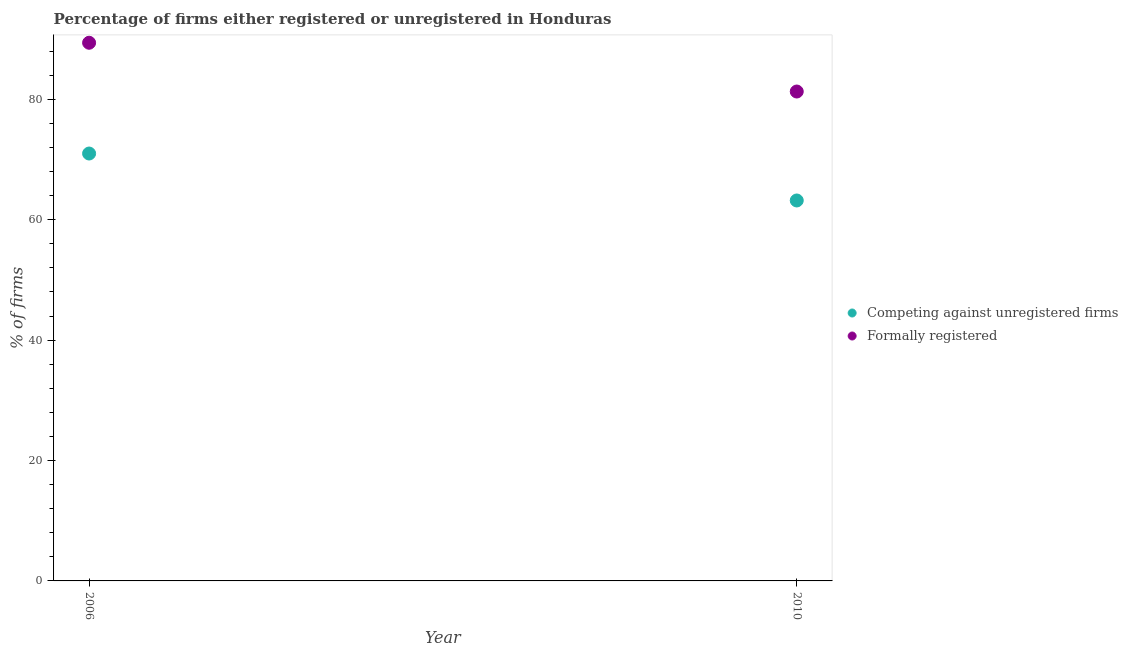Across all years, what is the maximum percentage of formally registered firms?
Give a very brief answer. 89.4. Across all years, what is the minimum percentage of formally registered firms?
Your answer should be very brief. 81.3. In which year was the percentage of registered firms maximum?
Your answer should be very brief. 2006. In which year was the percentage of formally registered firms minimum?
Your answer should be compact. 2010. What is the total percentage of formally registered firms in the graph?
Ensure brevity in your answer.  170.7. What is the difference between the percentage of formally registered firms in 2006 and that in 2010?
Your answer should be compact. 8.1. What is the difference between the percentage of formally registered firms in 2010 and the percentage of registered firms in 2006?
Your response must be concise. 10.3. What is the average percentage of formally registered firms per year?
Give a very brief answer. 85.35. In the year 2006, what is the difference between the percentage of registered firms and percentage of formally registered firms?
Your response must be concise. -18.4. What is the ratio of the percentage of formally registered firms in 2006 to that in 2010?
Give a very brief answer. 1.1. In how many years, is the percentage of registered firms greater than the average percentage of registered firms taken over all years?
Your answer should be compact. 1. Does the percentage of formally registered firms monotonically increase over the years?
Provide a short and direct response. No. Is the percentage of registered firms strictly less than the percentage of formally registered firms over the years?
Provide a succinct answer. Yes. How many years are there in the graph?
Offer a terse response. 2. Are the values on the major ticks of Y-axis written in scientific E-notation?
Offer a terse response. No. Where does the legend appear in the graph?
Provide a succinct answer. Center right. How many legend labels are there?
Offer a terse response. 2. How are the legend labels stacked?
Offer a very short reply. Vertical. What is the title of the graph?
Provide a short and direct response. Percentage of firms either registered or unregistered in Honduras. Does "Taxes on exports" appear as one of the legend labels in the graph?
Your response must be concise. No. What is the label or title of the Y-axis?
Ensure brevity in your answer.  % of firms. What is the % of firms of Formally registered in 2006?
Your answer should be compact. 89.4. What is the % of firms of Competing against unregistered firms in 2010?
Your answer should be compact. 63.2. What is the % of firms of Formally registered in 2010?
Your answer should be compact. 81.3. Across all years, what is the maximum % of firms of Formally registered?
Your answer should be compact. 89.4. Across all years, what is the minimum % of firms of Competing against unregistered firms?
Provide a short and direct response. 63.2. Across all years, what is the minimum % of firms in Formally registered?
Offer a terse response. 81.3. What is the total % of firms in Competing against unregistered firms in the graph?
Your response must be concise. 134.2. What is the total % of firms of Formally registered in the graph?
Provide a short and direct response. 170.7. What is the difference between the % of firms in Formally registered in 2006 and that in 2010?
Your response must be concise. 8.1. What is the difference between the % of firms in Competing against unregistered firms in 2006 and the % of firms in Formally registered in 2010?
Ensure brevity in your answer.  -10.3. What is the average % of firms of Competing against unregistered firms per year?
Provide a succinct answer. 67.1. What is the average % of firms in Formally registered per year?
Give a very brief answer. 85.35. In the year 2006, what is the difference between the % of firms in Competing against unregistered firms and % of firms in Formally registered?
Your response must be concise. -18.4. In the year 2010, what is the difference between the % of firms of Competing against unregistered firms and % of firms of Formally registered?
Your answer should be compact. -18.1. What is the ratio of the % of firms in Competing against unregistered firms in 2006 to that in 2010?
Keep it short and to the point. 1.12. What is the ratio of the % of firms in Formally registered in 2006 to that in 2010?
Your response must be concise. 1.1. What is the difference between the highest and the second highest % of firms of Competing against unregistered firms?
Your response must be concise. 7.8. What is the difference between the highest and the second highest % of firms in Formally registered?
Provide a short and direct response. 8.1. What is the difference between the highest and the lowest % of firms of Competing against unregistered firms?
Keep it short and to the point. 7.8. 